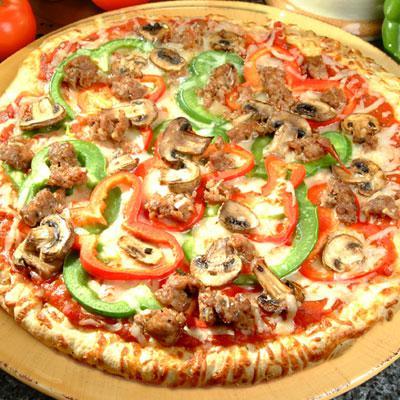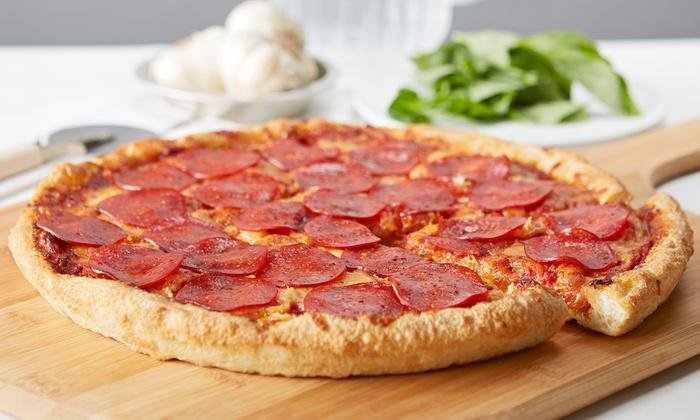The first image is the image on the left, the second image is the image on the right. Considering the images on both sides, is "In one of the images there are tomatoes visible on the table." valid? Answer yes or no. Yes. The first image is the image on the left, the second image is the image on the right. Analyze the images presented: Is the assertion "One pizza is pepperoni and the other has some green peppers." valid? Answer yes or no. Yes. 